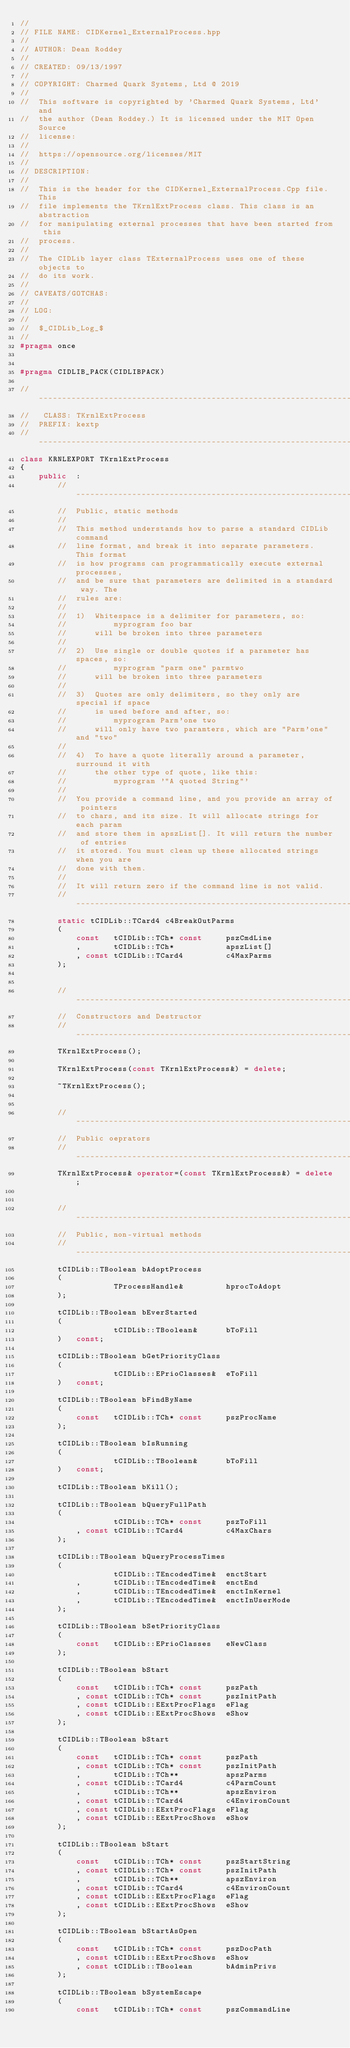<code> <loc_0><loc_0><loc_500><loc_500><_C++_>//
// FILE NAME: CIDKernel_ExternalProcess.hpp
//
// AUTHOR: Dean Roddey
//
// CREATED: 09/13/1997
//
// COPYRIGHT: Charmed Quark Systems, Ltd @ 2019
//
//  This software is copyrighted by 'Charmed Quark Systems, Ltd' and
//  the author (Dean Roddey.) It is licensed under the MIT Open Source
//  license:
//
//  https://opensource.org/licenses/MIT
//
// DESCRIPTION:
//
//  This is the header for the CIDKernel_ExternalProcess.Cpp file. This
//  file implements the TKrnlExtProcess class. This class is an abstraction
//  for manipulating external processes that have been started from this
//  process.
//
//  The CIDLib layer class TExternalProcess uses one of these objects to
//  do its work.
//
// CAVEATS/GOTCHAS:
//
// LOG:
//
//  $_CIDLib_Log_$
//
#pragma once


#pragma CIDLIB_PACK(CIDLIBPACK)

// ---------------------------------------------------------------------------
//   CLASS: TKrnlExtProcess
//  PREFIX: kextp
// ---------------------------------------------------------------------------
class KRNLEXPORT TKrnlExtProcess
{
    public  :
        // -------------------------------------------------------------------
        //  Public, static methods
        //
        //  This method understands how to parse a standard CIDLib command
        //  line format, and break it into separate parameters. This format
        //  is how programs can programmatically execute external processes,
        //  and be sure that parameters are delimited in a standard way. The
        //  rules are:
        //
        //  1)  Whitespace is a delimiter for parameters, so:
        //          myprogram foo bar
        //      will be broken into three parameters
        //
        //  2)  Use single or double quotes if a parameter has spaces, so:
        //          myprogram "parm one" parmtwo
        //      will be broken into three parameters
        //
        //  3)  Quotes are only delimiters, so they only are special if space
        //      is used before and after, so:
        //          myprogram Parm'one two
        //      will only have two paramters, which are "Parm'one" and "two"
        //
        //  4)  To have a quote literally around a parameter, surround it with
        //      the other type of quote, like this:
        //          myprogram '"A quoted String"'
        //
        //  You provide a command line, and you provide an array of pointers
        //  to chars, and its size. It will allocate strings for each param
        //  and store them in apszList[]. It will return the number of entries
        //  it stored. You must clean up these allocated strings when you are
        //  done with them.
        //
        //  It will return zero if the command line is not valid.
        // -------------------------------------------------------------------
        static tCIDLib::TCard4 c4BreakOutParms
        (
            const   tCIDLib::TCh* const     pszCmdLine
            ,       tCIDLib::TCh*           apszList[]
            , const tCIDLib::TCard4         c4MaxParms
        );


        // -------------------------------------------------------------------
        //  Constructors and Destructor
        // -------------------------------------------------------------------
        TKrnlExtProcess();

        TKrnlExtProcess(const TKrnlExtProcess&) = delete;

        ~TKrnlExtProcess();


        // -------------------------------------------------------------------
        //  Public oeprators
        // -------------------------------------------------------------------
        TKrnlExtProcess& operator=(const TKrnlExtProcess&) = delete;


        // -------------------------------------------------------------------
        //  Public, non-virtual methods
        // -------------------------------------------------------------------
        tCIDLib::TBoolean bAdoptProcess
        (
                    TProcessHandle&         hprocToAdopt
        );

        tCIDLib::TBoolean bEverStarted
        (
                    tCIDLib::TBoolean&      bToFill
        )   const;

        tCIDLib::TBoolean bGetPriorityClass
        (
                    tCIDLib::EPrioClasses&  eToFill
        )   const;

        tCIDLib::TBoolean bFindByName
        (
            const   tCIDLib::TCh* const     pszProcName
        );

        tCIDLib::TBoolean bIsRunning
        (
                    tCIDLib::TBoolean&      bToFill
        )   const;

        tCIDLib::TBoolean bKill();

        tCIDLib::TBoolean bQueryFullPath
        (
                    tCIDLib::TCh* const     pszToFill
            , const tCIDLib::TCard4         c4MaxChars
        );

        tCIDLib::TBoolean bQueryProcessTimes
        (
                    tCIDLib::TEncodedTime&  enctStart
            ,       tCIDLib::TEncodedTime&  enctEnd
            ,       tCIDLib::TEncodedTime&  enctInKernel
            ,       tCIDLib::TEncodedTime&  enctInUserMode
        );

        tCIDLib::TBoolean bSetPriorityClass
        (
            const   tCIDLib::EPrioClasses   eNewClass
        );

        tCIDLib::TBoolean bStart
        (
            const   tCIDLib::TCh* const     pszPath
            , const tCIDLib::TCh* const     pszInitPath
            , const tCIDLib::EExtProcFlags  eFlag
            , const tCIDLib::EExtProcShows  eShow
        );

        tCIDLib::TBoolean bStart
        (
            const   tCIDLib::TCh* const     pszPath
            , const tCIDLib::TCh* const     pszInitPath
            ,       tCIDLib::TCh**          apszParms
            , const tCIDLib::TCard4         c4ParmCount
            ,       tCIDLib::TCh**          apszEnviron
            , const tCIDLib::TCard4         c4EnvironCount
            , const tCIDLib::EExtProcFlags  eFlag
            , const tCIDLib::EExtProcShows  eShow
        );

        tCIDLib::TBoolean bStart
        (
            const   tCIDLib::TCh* const     pszStartString
            , const tCIDLib::TCh* const     pszInitPath
            ,       tCIDLib::TCh**          apszEnviron
            , const tCIDLib::TCard4         c4EnvironCount
            , const tCIDLib::EExtProcFlags  eFlag
            , const tCIDLib::EExtProcShows  eShow
        );

        tCIDLib::TBoolean bStartAsOpen
        (
            const   tCIDLib::TCh* const     pszDocPath
            , const tCIDLib::EExtProcShows  eShow
            , const tCIDLib::TBoolean       bAdminPrivs
        );

        tCIDLib::TBoolean bSystemEscape
        (
            const   tCIDLib::TCh* const     pszCommandLine</code> 